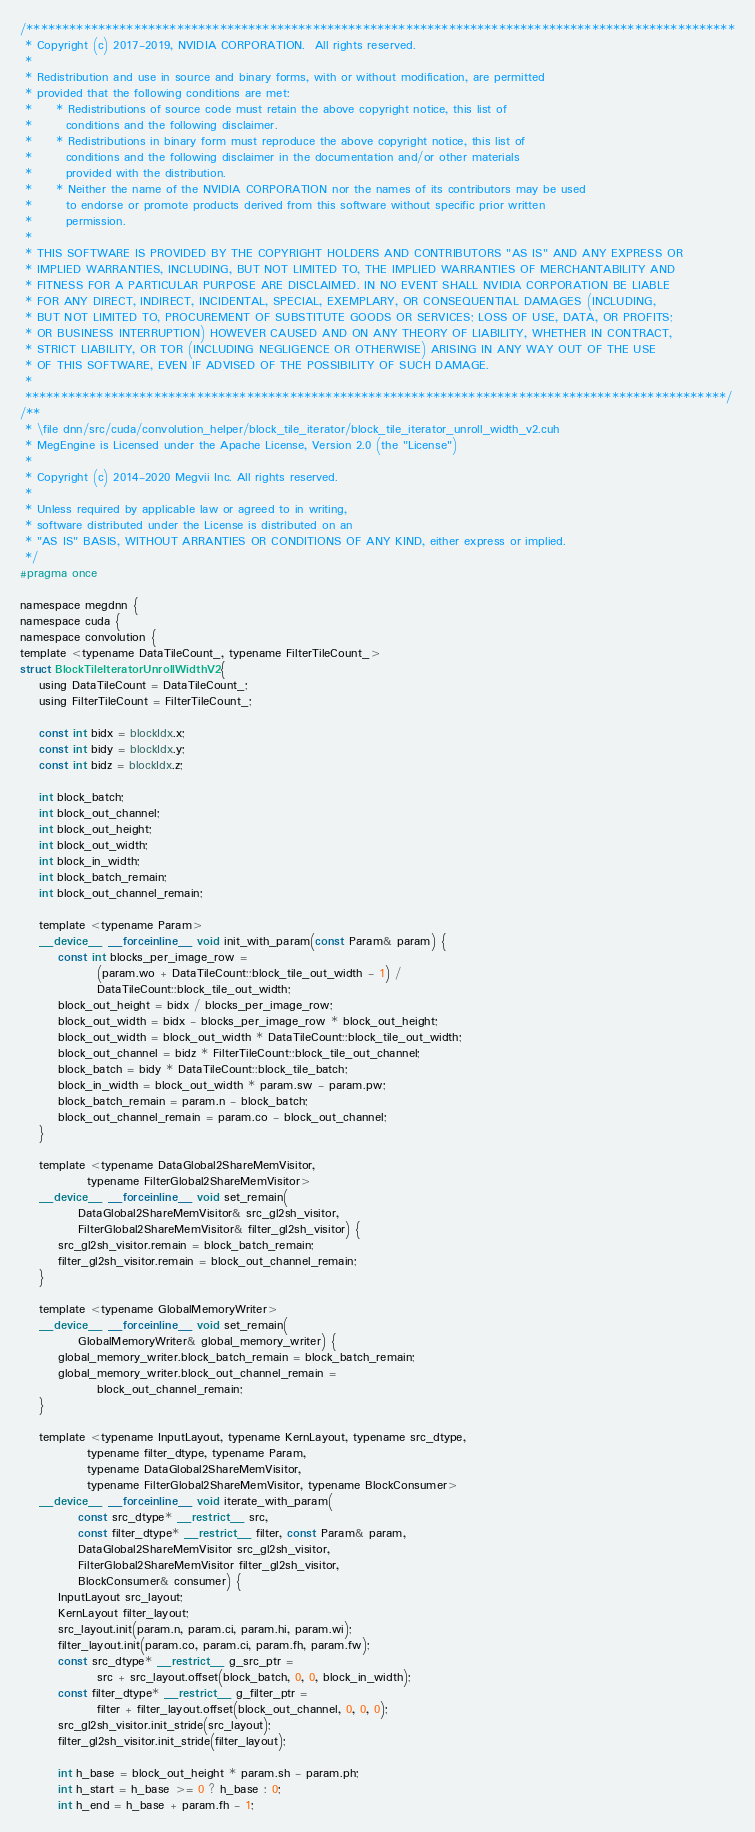Convert code to text. <code><loc_0><loc_0><loc_500><loc_500><_Cuda_>/***************************************************************************************************
 * Copyright (c) 2017-2019, NVIDIA CORPORATION.  All rights reserved.
 *
 * Redistribution and use in source and binary forms, with or without modification, are permitted
 * provided that the following conditions are met:
 *     * Redistributions of source code must retain the above copyright notice, this list of
 *       conditions and the following disclaimer.
 *     * Redistributions in binary form must reproduce the above copyright notice, this list of
 *       conditions and the following disclaimer in the documentation and/or other materials
 *       provided with the distribution.
 *     * Neither the name of the NVIDIA CORPORATION nor the names of its contributors may be used
 *       to endorse or promote products derived from this software without specific prior written
 *       permission.
 *
 * THIS SOFTWARE IS PROVIDED BY THE COPYRIGHT HOLDERS AND CONTRIBUTORS "AS IS" AND ANY EXPRESS OR
 * IMPLIED WARRANTIES, INCLUDING, BUT NOT LIMITED TO, THE IMPLIED WARRANTIES OF MERCHANTABILITY AND
 * FITNESS FOR A PARTICULAR PURPOSE ARE DISCLAIMED. IN NO EVENT SHALL NVIDIA CORPORATION BE LIABLE
 * FOR ANY DIRECT, INDIRECT, INCIDENTAL, SPECIAL, EXEMPLARY, OR CONSEQUENTIAL DAMAGES (INCLUDING,
 * BUT NOT LIMITED TO, PROCUREMENT OF SUBSTITUTE GOODS OR SERVICES; LOSS OF USE, DATA, OR PROFITS;
 * OR BUSINESS INTERRUPTION) HOWEVER CAUSED AND ON ANY THEORY OF LIABILITY, WHETHER IN CONTRACT,
 * STRICT LIABILITY, OR TOR (INCLUDING NEGLIGENCE OR OTHERWISE) ARISING IN ANY WAY OUT OF THE USE
 * OF THIS SOFTWARE, EVEN IF ADVISED OF THE POSSIBILITY OF SUCH DAMAGE.
 *
 **************************************************************************************************/
/**
 * \file dnn/src/cuda/convolution_helper/block_tile_iterator/block_tile_iterator_unroll_width_v2.cuh
 * MegEngine is Licensed under the Apache License, Version 2.0 (the "License")
 *
 * Copyright (c) 2014-2020 Megvii Inc. All rights reserved.
 *
 * Unless required by applicable law or agreed to in writing,
 * software distributed under the License is distributed on an
 * "AS IS" BASIS, WITHOUT ARRANTIES OR CONDITIONS OF ANY KIND, either express or implied.
 */
#pragma once

namespace megdnn {
namespace cuda {
namespace convolution {
template <typename DataTileCount_, typename FilterTileCount_>
struct BlockTileIteratorUnrollWidthV2 {
    using DataTileCount = DataTileCount_;
    using FilterTileCount = FilterTileCount_;

    const int bidx = blockIdx.x;
    const int bidy = blockIdx.y;
    const int bidz = blockIdx.z;

    int block_batch;
    int block_out_channel;
    int block_out_height;
    int block_out_width;
    int block_in_width;
    int block_batch_remain;
    int block_out_channel_remain;

    template <typename Param>
    __device__ __forceinline__ void init_with_param(const Param& param) {
        const int blocks_per_image_row =
                (param.wo + DataTileCount::block_tile_out_width - 1) /
                DataTileCount::block_tile_out_width;
        block_out_height = bidx / blocks_per_image_row;
        block_out_width = bidx - blocks_per_image_row * block_out_height;
        block_out_width = block_out_width * DataTileCount::block_tile_out_width;
        block_out_channel = bidz * FilterTileCount::block_tile_out_channel;
        block_batch = bidy * DataTileCount::block_tile_batch;
        block_in_width = block_out_width * param.sw - param.pw;
        block_batch_remain = param.n - block_batch;
        block_out_channel_remain = param.co - block_out_channel;
    }

    template <typename DataGlobal2ShareMemVisitor,
              typename FilterGlobal2ShareMemVisitor>
    __device__ __forceinline__ void set_remain(
            DataGlobal2ShareMemVisitor& src_gl2sh_visitor,
            FilterGlobal2ShareMemVisitor& filter_gl2sh_visitor) {
        src_gl2sh_visitor.remain = block_batch_remain;
        filter_gl2sh_visitor.remain = block_out_channel_remain;
    }

    template <typename GlobalMemoryWriter>
    __device__ __forceinline__ void set_remain(
            GlobalMemoryWriter& global_memory_writer) {
        global_memory_writer.block_batch_remain = block_batch_remain;
        global_memory_writer.block_out_channel_remain =
                block_out_channel_remain;
    }

    template <typename InputLayout, typename KernLayout, typename src_dtype,
              typename filter_dtype, typename Param,
              typename DataGlobal2ShareMemVisitor,
              typename FilterGlobal2ShareMemVisitor, typename BlockConsumer>
    __device__ __forceinline__ void iterate_with_param(
            const src_dtype* __restrict__ src,
            const filter_dtype* __restrict__ filter, const Param& param,
            DataGlobal2ShareMemVisitor src_gl2sh_visitor,
            FilterGlobal2ShareMemVisitor filter_gl2sh_visitor,
            BlockConsumer& consumer) {
        InputLayout src_layout;
        KernLayout filter_layout;
        src_layout.init(param.n, param.ci, param.hi, param.wi);
        filter_layout.init(param.co, param.ci, param.fh, param.fw);
        const src_dtype* __restrict__ g_src_ptr =
                src + src_layout.offset(block_batch, 0, 0, block_in_width);
        const filter_dtype* __restrict__ g_filter_ptr =
                filter + filter_layout.offset(block_out_channel, 0, 0, 0);
        src_gl2sh_visitor.init_stride(src_layout);
        filter_gl2sh_visitor.init_stride(filter_layout);

        int h_base = block_out_height * param.sh - param.ph;
        int h_start = h_base >= 0 ? h_base : 0;
        int h_end = h_base + param.fh - 1;</code> 